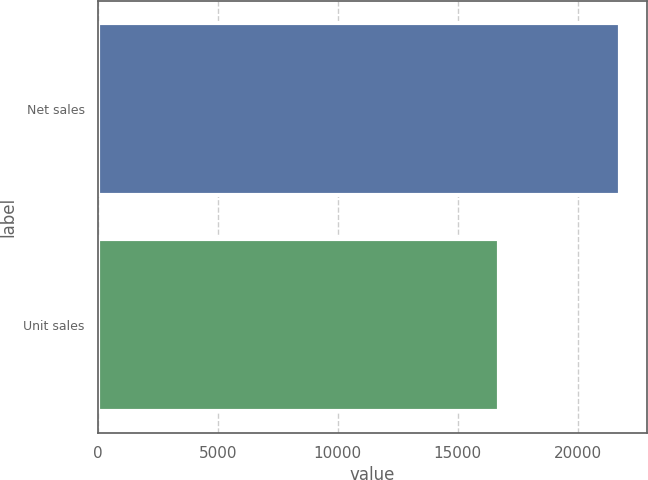Convert chart to OTSL. <chart><loc_0><loc_0><loc_500><loc_500><bar_chart><fcel>Net sales<fcel>Unit sales<nl><fcel>21783<fcel>16735<nl></chart> 